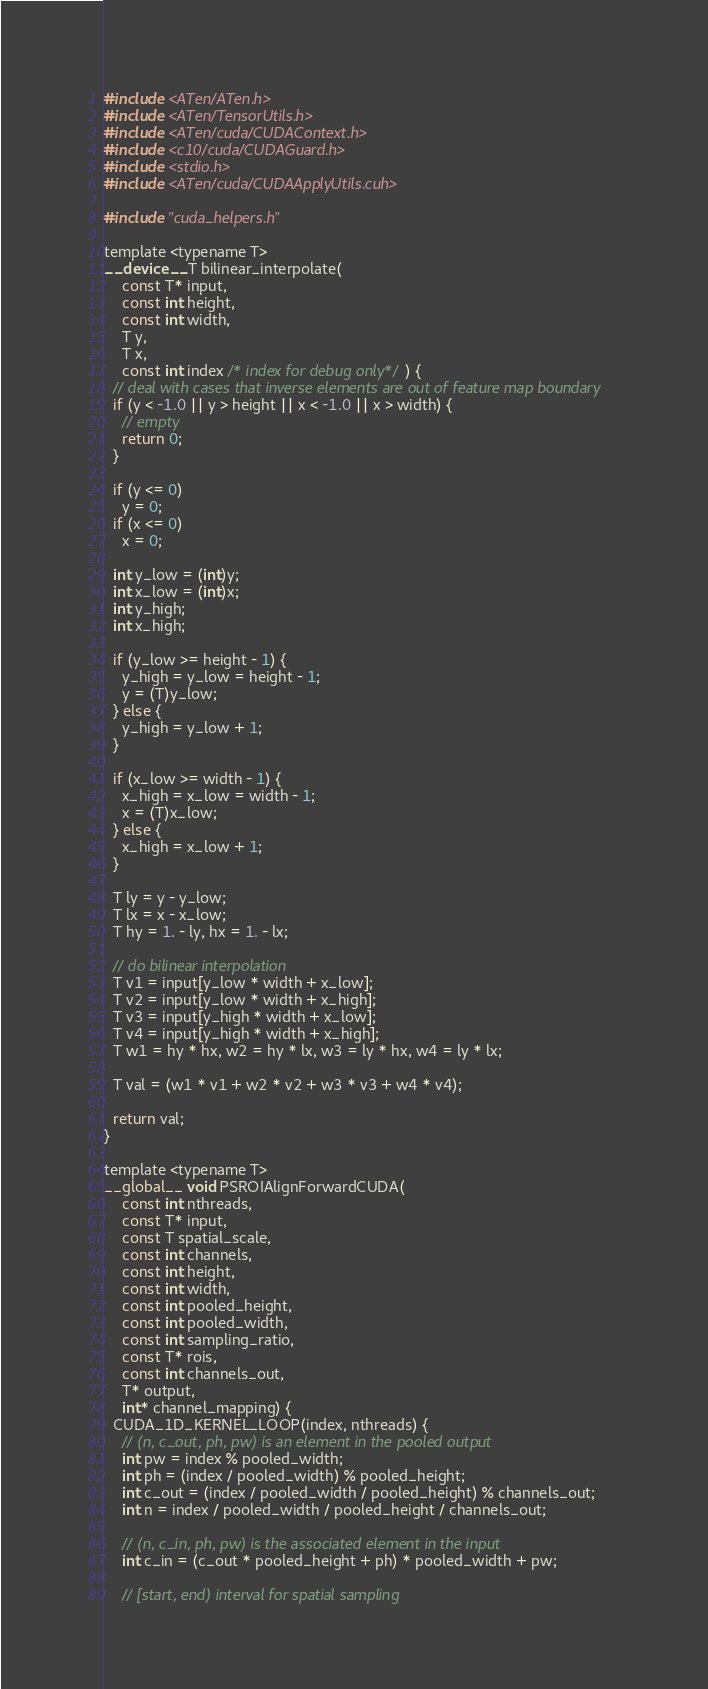<code> <loc_0><loc_0><loc_500><loc_500><_Cuda_>#include <ATen/ATen.h>
#include <ATen/TensorUtils.h>
#include <ATen/cuda/CUDAContext.h>
#include <c10/cuda/CUDAGuard.h>
#include <stdio.h>
#include <ATen/cuda/CUDAApplyUtils.cuh>

#include "cuda_helpers.h"

template <typename T>
__device__ T bilinear_interpolate(
    const T* input,
    const int height,
    const int width,
    T y,
    T x,
    const int index /* index for debug only*/) {
  // deal with cases that inverse elements are out of feature map boundary
  if (y < -1.0 || y > height || x < -1.0 || x > width) {
    // empty
    return 0;
  }

  if (y <= 0)
    y = 0;
  if (x <= 0)
    x = 0;

  int y_low = (int)y;
  int x_low = (int)x;
  int y_high;
  int x_high;

  if (y_low >= height - 1) {
    y_high = y_low = height - 1;
    y = (T)y_low;
  } else {
    y_high = y_low + 1;
  }

  if (x_low >= width - 1) {
    x_high = x_low = width - 1;
    x = (T)x_low;
  } else {
    x_high = x_low + 1;
  }

  T ly = y - y_low;
  T lx = x - x_low;
  T hy = 1. - ly, hx = 1. - lx;

  // do bilinear interpolation
  T v1 = input[y_low * width + x_low];
  T v2 = input[y_low * width + x_high];
  T v3 = input[y_high * width + x_low];
  T v4 = input[y_high * width + x_high];
  T w1 = hy * hx, w2 = hy * lx, w3 = ly * hx, w4 = ly * lx;

  T val = (w1 * v1 + w2 * v2 + w3 * v3 + w4 * v4);

  return val;
}

template <typename T>
__global__ void PSROIAlignForwardCUDA(
    const int nthreads,
    const T* input,
    const T spatial_scale,
    const int channels,
    const int height,
    const int width,
    const int pooled_height,
    const int pooled_width,
    const int sampling_ratio,
    const T* rois,
    const int channels_out,
    T* output,
    int* channel_mapping) {
  CUDA_1D_KERNEL_LOOP(index, nthreads) {
    // (n, c_out, ph, pw) is an element in the pooled output
    int pw = index % pooled_width;
    int ph = (index / pooled_width) % pooled_height;
    int c_out = (index / pooled_width / pooled_height) % channels_out;
    int n = index / pooled_width / pooled_height / channels_out;

    // (n, c_in, ph, pw) is the associated element in the input
    int c_in = (c_out * pooled_height + ph) * pooled_width + pw;

    // [start, end) interval for spatial sampling</code> 